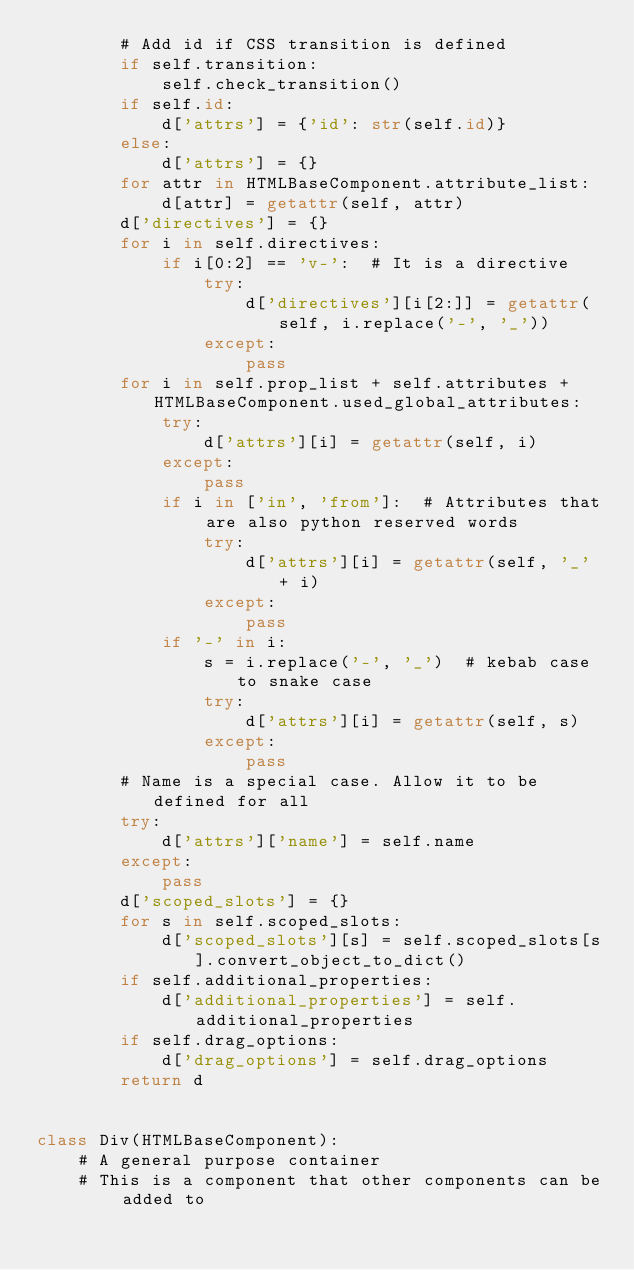Convert code to text. <code><loc_0><loc_0><loc_500><loc_500><_Python_>        # Add id if CSS transition is defined
        if self.transition:
            self.check_transition()
        if self.id:
            d['attrs'] = {'id': str(self.id)}
        else:
            d['attrs'] = {}
        for attr in HTMLBaseComponent.attribute_list:
            d[attr] = getattr(self, attr)
        d['directives'] = {}
        for i in self.directives:
            if i[0:2] == 'v-':  # It is a directive
                try:
                    d['directives'][i[2:]] = getattr(self, i.replace('-', '_'))
                except:
                    pass
        for i in self.prop_list + self.attributes + HTMLBaseComponent.used_global_attributes:
            try:
                d['attrs'][i] = getattr(self, i)
            except:
                pass
            if i in ['in', 'from']:  # Attributes that are also python reserved words
                try:
                    d['attrs'][i] = getattr(self, '_' + i)
                except:
                    pass
            if '-' in i:
                s = i.replace('-', '_')  # kebab case to snake case
                try:
                    d['attrs'][i] = getattr(self, s)
                except:
                    pass
        # Name is a special case. Allow it to be defined for all
        try:
            d['attrs']['name'] = self.name
        except:
            pass
        d['scoped_slots'] = {}
        for s in self.scoped_slots:
            d['scoped_slots'][s] = self.scoped_slots[s].convert_object_to_dict()
        if self.additional_properties:
            d['additional_properties'] = self.additional_properties
        if self.drag_options:
            d['drag_options'] = self.drag_options
        return d


class Div(HTMLBaseComponent):
    # A general purpose container
    # This is a component that other components can be added to
</code> 